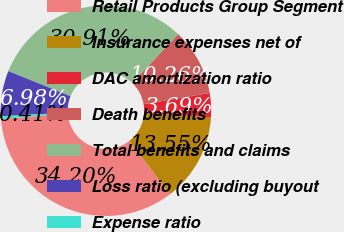<chart> <loc_0><loc_0><loc_500><loc_500><pie_chart><fcel>Retail Products Group Segment<fcel>Insurance expenses net of<fcel>DAC amortization ratio<fcel>Death benefits<fcel>Total benefits and claims<fcel>Loss ratio (excluding buyout<fcel>Expense ratio<nl><fcel>34.2%<fcel>13.55%<fcel>3.69%<fcel>10.26%<fcel>30.91%<fcel>6.98%<fcel>0.41%<nl></chart> 